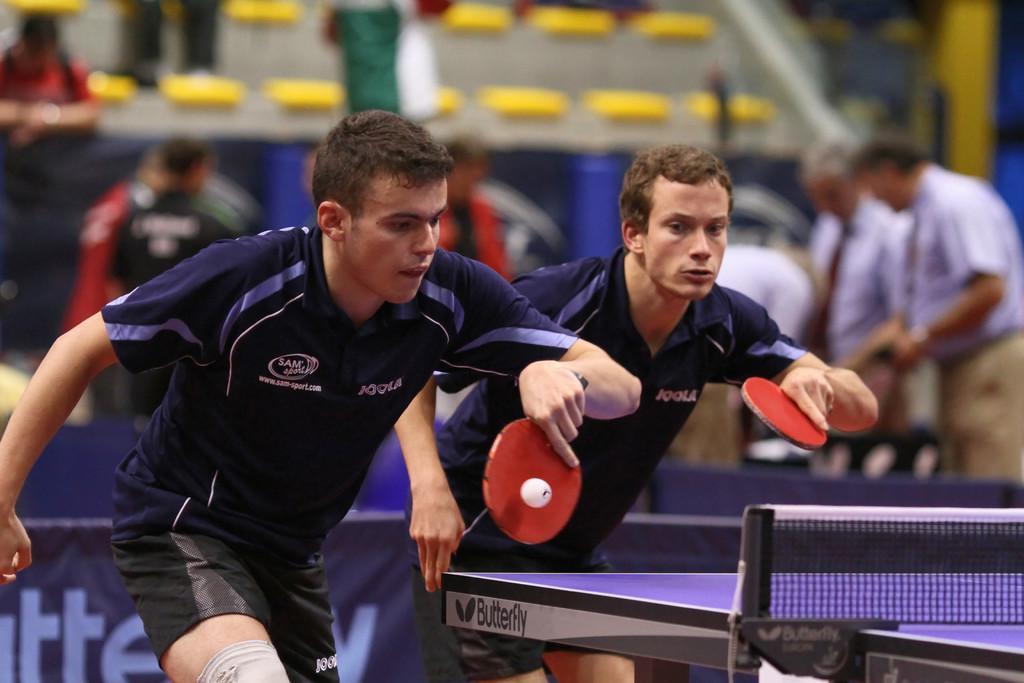Can you describe this image briefly? In this image i can see 2 persons holding tennis bat in their hands, and I can see a tennis ball over here, I can see tennis table in front of them and In the background i can see few people standing and few chairs. 